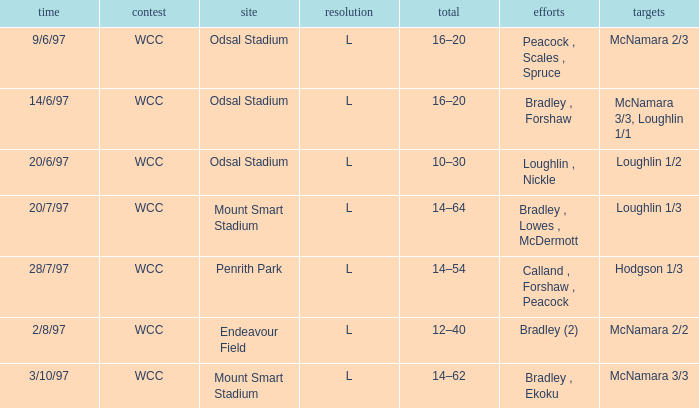What were the tries on 14/6/97? Bradley , Forshaw. 